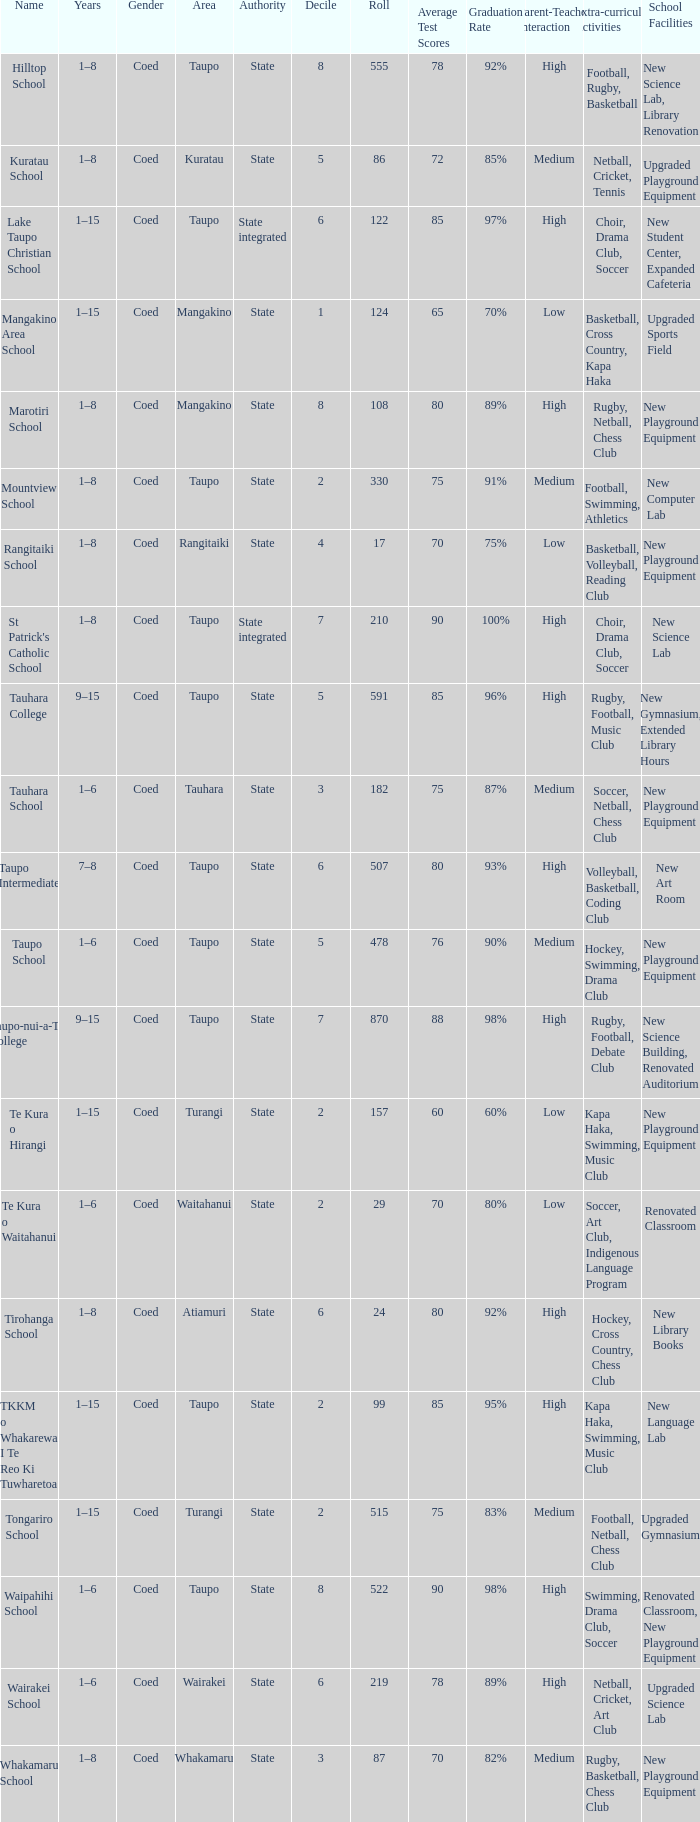Where is the state-controlled educational institution that consists of more than 157 enrolled students located? Taupo, Taupo, Taupo, Tauhara, Taupo, Taupo, Taupo, Turangi, Taupo, Wairakei. 